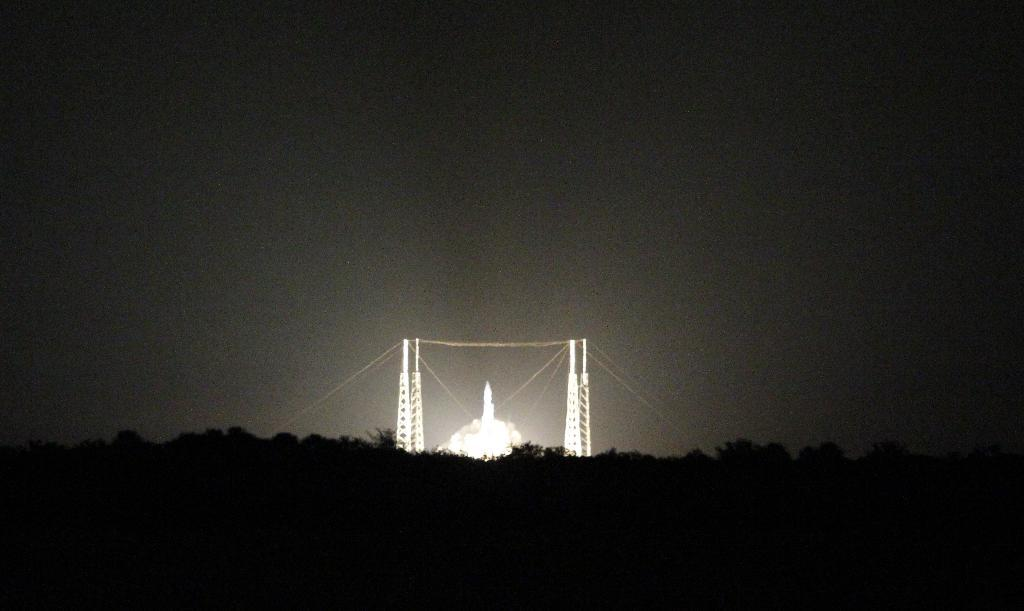What is the lighting condition of the front side of the image? The front side of the image is dark. What structures can be seen in the background of the image? There are towers with wires in the background. What else can be seen in the background of the image? There is light visible in the background, and the sky is also visible. What type of development is taking place in the image? There is no specific development or activity taking place in the image; it primarily features towers with wires and a dark front side. How many bits of information can be seen in the image? The concept of "bits" is not applicable to the image, as it refers to digital data and the image is not a digital file. 